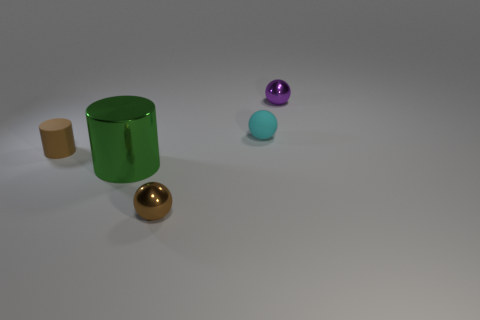There is a small brown object in front of the brown thing to the left of the large green metal cylinder; is there a metallic object right of it?
Ensure brevity in your answer.  Yes. Is there anything else that is the same shape as the cyan object?
Offer a terse response. Yes. Do the small metal object behind the metallic cylinder and the matte object behind the small brown matte thing have the same color?
Ensure brevity in your answer.  No. Is there a large purple matte cylinder?
Ensure brevity in your answer.  No. There is a object that is the same color as the small cylinder; what is it made of?
Make the answer very short. Metal. What is the size of the brown thing on the right side of the large thing that is in front of the metal object that is right of the rubber sphere?
Provide a succinct answer. Small. There is a green thing; is its shape the same as the tiny shiny object that is on the left side of the purple object?
Offer a terse response. No. Are there any matte cylinders of the same color as the tiny rubber ball?
Your answer should be very brief. No. How many balls are small brown metallic objects or large blue things?
Ensure brevity in your answer.  1. Are there any other big shiny things that have the same shape as the purple metallic object?
Offer a terse response. No. 